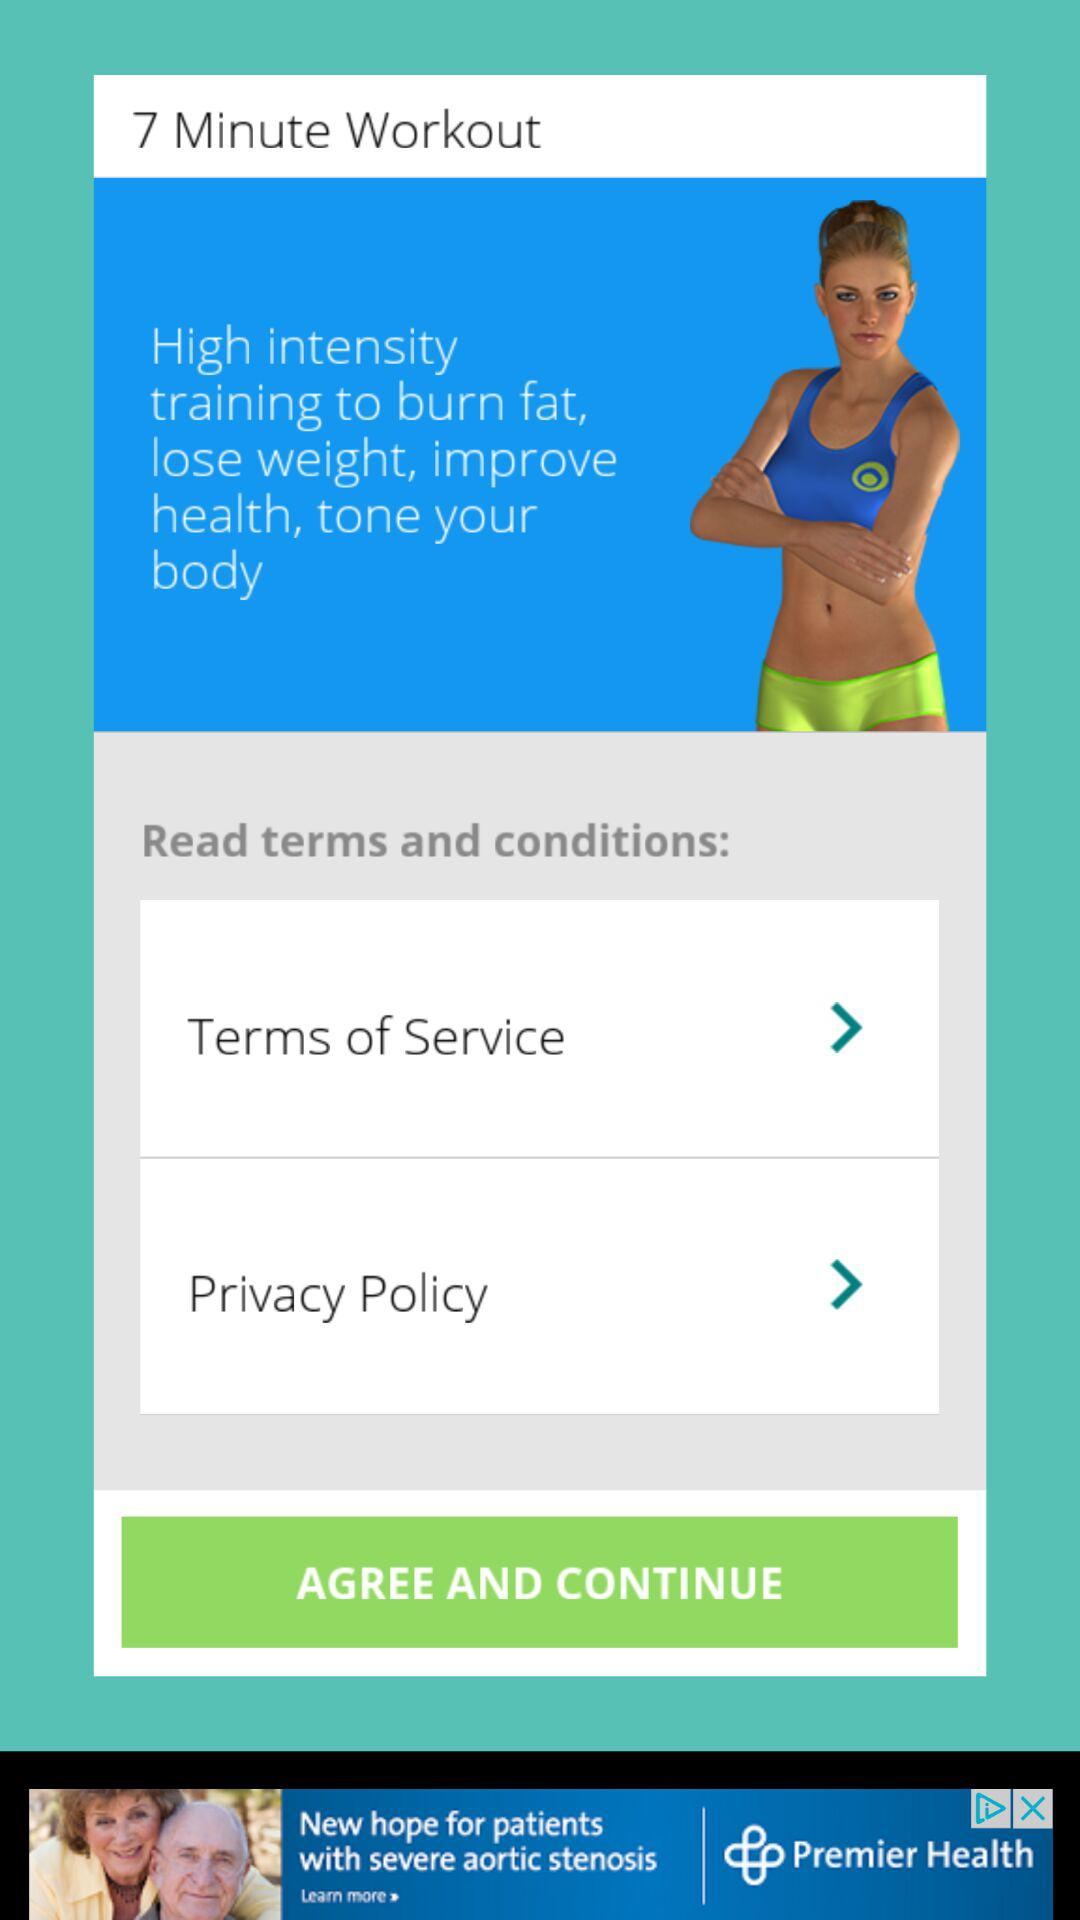How many arrows are there in the terms and conditions section?
Answer the question using a single word or phrase. 2 